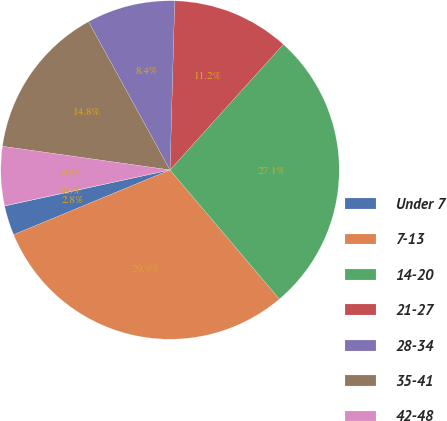Convert chart. <chart><loc_0><loc_0><loc_500><loc_500><pie_chart><fcel>Under 7<fcel>7-13<fcel>14-20<fcel>21-27<fcel>28-34<fcel>35-41<fcel>42-48<fcel>49-55<nl><fcel>2.83%<fcel>29.94%<fcel>27.13%<fcel>11.24%<fcel>8.44%<fcel>14.77%<fcel>5.63%<fcel>0.02%<nl></chart> 